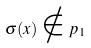<formula> <loc_0><loc_0><loc_500><loc_500>\sigma ( x ) \notin p _ { 1 }</formula> 